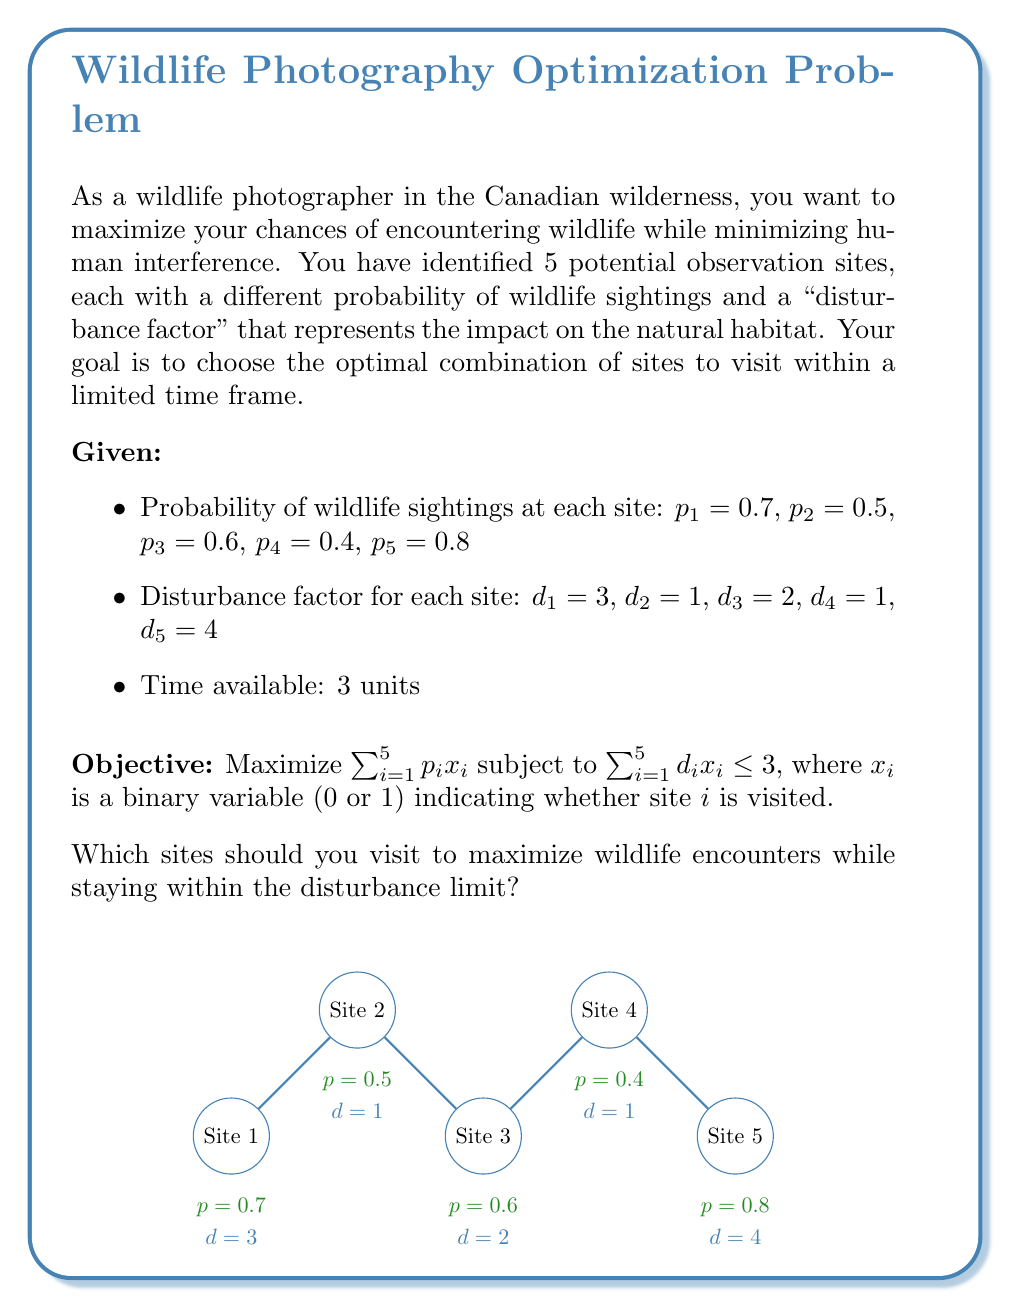Could you help me with this problem? To solve this problem, we'll use the branch and bound method for integer programming:

1) First, let's set up the linear programming relaxation:
   Maximize: $0.7x_1 + 0.5x_2 + 0.6x_3 + 0.4x_4 + 0.8x_5$
   Subject to: $3x_1 + x_2 + 2x_3 + x_4 + 4x_5 \leq 3$
               $0 \leq x_i \leq 1$ for all $i$

2) Solving this relaxation gives us:
   $x_1 = 0$, $x_2 = 1$, $x_3 = 1$, $x_4 = 0$, $x_5 = 0.25$
   Objective value: $0.5 + 0.6 + 0.2 = 1.3$

3) Since $x_5$ is fractional, we branch on it:
   Branch 1: $x_5 = 0$
   Branch 2: $x_5 = 1$

4) Solving Branch 1:
   $x_1 = 0$, $x_2 = 1$, $x_3 = 1$, $x_4 = 0$, $x_5 = 0$
   Objective value: $0.5 + 0.6 = 1.1$
   This is an integer solution.

5) Solving Branch 2:
   With $x_5 = 1$, we have no room for other sites due to the disturbance constraint.
   $x_1 = 0$, $x_2 = 0$, $x_3 = 0$, $x_4 = 0$, $x_5 = 1$
   Objective value: $0.8$

6) The best integer solution is from Branch 1, with an objective value of 1.1.

Therefore, the optimal solution is to visit Site 2 and Site 3.
Answer: Visit Sites 2 and 3 